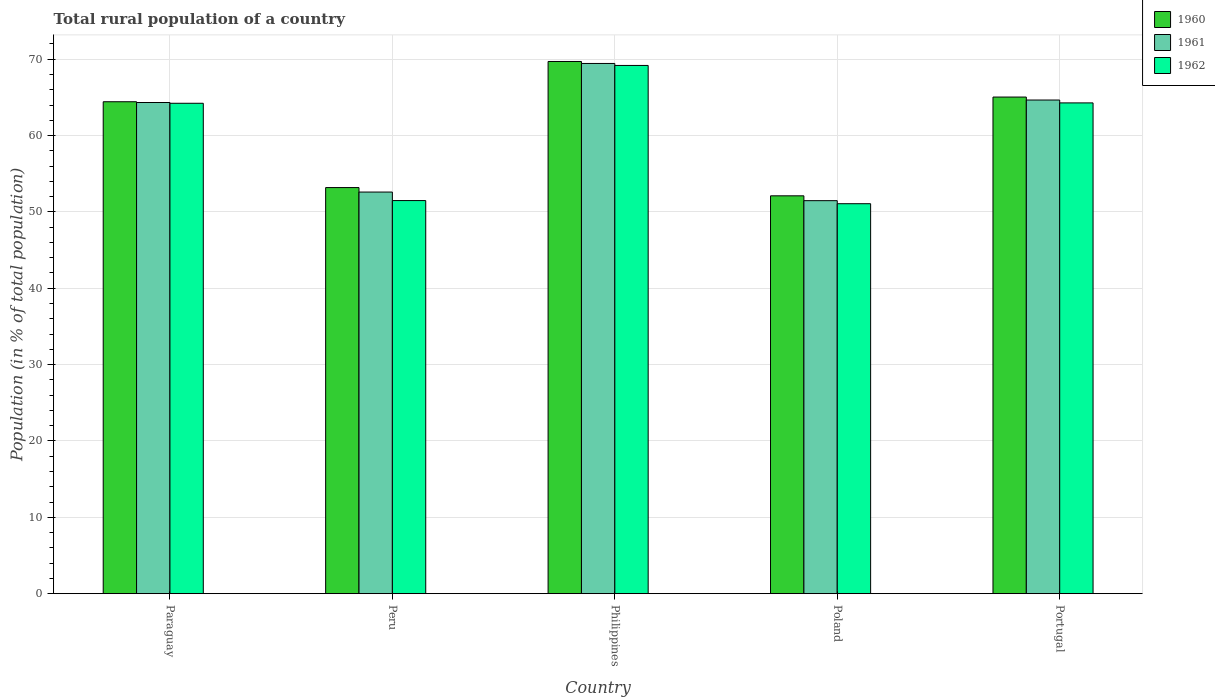How many different coloured bars are there?
Provide a short and direct response. 3. In how many cases, is the number of bars for a given country not equal to the number of legend labels?
Provide a short and direct response. 0. What is the rural population in 1961 in Paraguay?
Your response must be concise. 64.33. Across all countries, what is the maximum rural population in 1962?
Make the answer very short. 69.18. Across all countries, what is the minimum rural population in 1960?
Ensure brevity in your answer.  52.11. In which country was the rural population in 1961 minimum?
Provide a succinct answer. Poland. What is the total rural population in 1961 in the graph?
Your answer should be compact. 302.51. What is the difference between the rural population in 1962 in Paraguay and that in Portugal?
Offer a terse response. -0.05. What is the difference between the rural population in 1962 in Portugal and the rural population in 1960 in Paraguay?
Offer a terse response. -0.15. What is the average rural population in 1962 per country?
Keep it short and to the point. 60.05. What is the difference between the rural population of/in 1962 and rural population of/in 1961 in Philippines?
Give a very brief answer. -0.26. What is the ratio of the rural population in 1960 in Paraguay to that in Poland?
Keep it short and to the point. 1.24. What is the difference between the highest and the second highest rural population in 1961?
Keep it short and to the point. 0.33. What is the difference between the highest and the lowest rural population in 1960?
Make the answer very short. 17.6. In how many countries, is the rural population in 1960 greater than the average rural population in 1960 taken over all countries?
Your answer should be very brief. 3. Is it the case that in every country, the sum of the rural population in 1960 and rural population in 1961 is greater than the rural population in 1962?
Provide a short and direct response. Yes. How many bars are there?
Make the answer very short. 15. What is the difference between two consecutive major ticks on the Y-axis?
Provide a short and direct response. 10. Does the graph contain any zero values?
Your answer should be compact. No. Does the graph contain grids?
Keep it short and to the point. Yes. Where does the legend appear in the graph?
Your response must be concise. Top right. How are the legend labels stacked?
Provide a succinct answer. Vertical. What is the title of the graph?
Your answer should be compact. Total rural population of a country. What is the label or title of the X-axis?
Your answer should be compact. Country. What is the label or title of the Y-axis?
Make the answer very short. Population (in % of total population). What is the Population (in % of total population) in 1960 in Paraguay?
Offer a very short reply. 64.43. What is the Population (in % of total population) of 1961 in Paraguay?
Give a very brief answer. 64.33. What is the Population (in % of total population) in 1962 in Paraguay?
Your answer should be very brief. 64.23. What is the Population (in % of total population) of 1960 in Peru?
Keep it short and to the point. 53.19. What is the Population (in % of total population) of 1961 in Peru?
Your answer should be compact. 52.6. What is the Population (in % of total population) of 1962 in Peru?
Make the answer very short. 51.49. What is the Population (in % of total population) in 1960 in Philippines?
Give a very brief answer. 69.7. What is the Population (in % of total population) of 1961 in Philippines?
Provide a short and direct response. 69.44. What is the Population (in % of total population) in 1962 in Philippines?
Your response must be concise. 69.18. What is the Population (in % of total population) of 1960 in Poland?
Provide a succinct answer. 52.11. What is the Population (in % of total population) of 1961 in Poland?
Provide a short and direct response. 51.47. What is the Population (in % of total population) of 1962 in Poland?
Your answer should be very brief. 51.07. What is the Population (in % of total population) in 1960 in Portugal?
Your answer should be very brief. 65.05. What is the Population (in % of total population) in 1961 in Portugal?
Keep it short and to the point. 64.66. What is the Population (in % of total population) of 1962 in Portugal?
Your answer should be compact. 64.28. Across all countries, what is the maximum Population (in % of total population) in 1960?
Provide a succinct answer. 69.7. Across all countries, what is the maximum Population (in % of total population) of 1961?
Your response must be concise. 69.44. Across all countries, what is the maximum Population (in % of total population) in 1962?
Keep it short and to the point. 69.18. Across all countries, what is the minimum Population (in % of total population) of 1960?
Your response must be concise. 52.11. Across all countries, what is the minimum Population (in % of total population) in 1961?
Your answer should be compact. 51.47. Across all countries, what is the minimum Population (in % of total population) in 1962?
Ensure brevity in your answer.  51.07. What is the total Population (in % of total population) in 1960 in the graph?
Give a very brief answer. 304.48. What is the total Population (in % of total population) of 1961 in the graph?
Keep it short and to the point. 302.51. What is the total Population (in % of total population) of 1962 in the graph?
Provide a short and direct response. 300.25. What is the difference between the Population (in % of total population) of 1960 in Paraguay and that in Peru?
Ensure brevity in your answer.  11.24. What is the difference between the Population (in % of total population) in 1961 in Paraguay and that in Peru?
Make the answer very short. 11.73. What is the difference between the Population (in % of total population) in 1962 in Paraguay and that in Peru?
Make the answer very short. 12.74. What is the difference between the Population (in % of total population) of 1960 in Paraguay and that in Philippines?
Your response must be concise. -5.27. What is the difference between the Population (in % of total population) in 1961 in Paraguay and that in Philippines?
Offer a very short reply. -5.12. What is the difference between the Population (in % of total population) of 1962 in Paraguay and that in Philippines?
Provide a short and direct response. -4.96. What is the difference between the Population (in % of total population) in 1960 in Paraguay and that in Poland?
Give a very brief answer. 12.32. What is the difference between the Population (in % of total population) of 1961 in Paraguay and that in Poland?
Provide a succinct answer. 12.86. What is the difference between the Population (in % of total population) of 1962 in Paraguay and that in Poland?
Your answer should be very brief. 13.15. What is the difference between the Population (in % of total population) in 1960 in Paraguay and that in Portugal?
Make the answer very short. -0.61. What is the difference between the Population (in % of total population) in 1961 in Paraguay and that in Portugal?
Keep it short and to the point. -0.33. What is the difference between the Population (in % of total population) of 1962 in Paraguay and that in Portugal?
Your response must be concise. -0.05. What is the difference between the Population (in % of total population) in 1960 in Peru and that in Philippines?
Your answer should be very brief. -16.51. What is the difference between the Population (in % of total population) of 1961 in Peru and that in Philippines?
Your response must be concise. -16.84. What is the difference between the Population (in % of total population) of 1962 in Peru and that in Philippines?
Ensure brevity in your answer.  -17.7. What is the difference between the Population (in % of total population) in 1960 in Peru and that in Poland?
Provide a succinct answer. 1.08. What is the difference between the Population (in % of total population) in 1961 in Peru and that in Poland?
Provide a succinct answer. 1.13. What is the difference between the Population (in % of total population) of 1962 in Peru and that in Poland?
Your answer should be very brief. 0.41. What is the difference between the Population (in % of total population) in 1960 in Peru and that in Portugal?
Offer a terse response. -11.86. What is the difference between the Population (in % of total population) of 1961 in Peru and that in Portugal?
Offer a very short reply. -12.05. What is the difference between the Population (in % of total population) in 1962 in Peru and that in Portugal?
Your answer should be very brief. -12.79. What is the difference between the Population (in % of total population) of 1960 in Philippines and that in Poland?
Ensure brevity in your answer.  17.59. What is the difference between the Population (in % of total population) in 1961 in Philippines and that in Poland?
Provide a succinct answer. 17.97. What is the difference between the Population (in % of total population) in 1962 in Philippines and that in Poland?
Keep it short and to the point. 18.11. What is the difference between the Population (in % of total population) in 1960 in Philippines and that in Portugal?
Keep it short and to the point. 4.66. What is the difference between the Population (in % of total population) in 1961 in Philippines and that in Portugal?
Give a very brief answer. 4.79. What is the difference between the Population (in % of total population) in 1962 in Philippines and that in Portugal?
Your answer should be compact. 4.91. What is the difference between the Population (in % of total population) in 1960 in Poland and that in Portugal?
Your response must be concise. -12.94. What is the difference between the Population (in % of total population) in 1961 in Poland and that in Portugal?
Keep it short and to the point. -13.18. What is the difference between the Population (in % of total population) in 1962 in Poland and that in Portugal?
Your response must be concise. -13.2. What is the difference between the Population (in % of total population) in 1960 in Paraguay and the Population (in % of total population) in 1961 in Peru?
Your response must be concise. 11.83. What is the difference between the Population (in % of total population) in 1960 in Paraguay and the Population (in % of total population) in 1962 in Peru?
Make the answer very short. 12.95. What is the difference between the Population (in % of total population) of 1961 in Paraguay and the Population (in % of total population) of 1962 in Peru?
Your answer should be compact. 12.84. What is the difference between the Population (in % of total population) of 1960 in Paraguay and the Population (in % of total population) of 1961 in Philippines?
Give a very brief answer. -5.01. What is the difference between the Population (in % of total population) in 1960 in Paraguay and the Population (in % of total population) in 1962 in Philippines?
Offer a terse response. -4.75. What is the difference between the Population (in % of total population) in 1961 in Paraguay and the Population (in % of total population) in 1962 in Philippines?
Provide a short and direct response. -4.85. What is the difference between the Population (in % of total population) of 1960 in Paraguay and the Population (in % of total population) of 1961 in Poland?
Make the answer very short. 12.96. What is the difference between the Population (in % of total population) of 1960 in Paraguay and the Population (in % of total population) of 1962 in Poland?
Keep it short and to the point. 13.36. What is the difference between the Population (in % of total population) in 1961 in Paraguay and the Population (in % of total population) in 1962 in Poland?
Offer a terse response. 13.26. What is the difference between the Population (in % of total population) of 1960 in Paraguay and the Population (in % of total population) of 1961 in Portugal?
Give a very brief answer. -0.23. What is the difference between the Population (in % of total population) of 1960 in Paraguay and the Population (in % of total population) of 1962 in Portugal?
Give a very brief answer. 0.15. What is the difference between the Population (in % of total population) of 1961 in Paraguay and the Population (in % of total population) of 1962 in Portugal?
Keep it short and to the point. 0.05. What is the difference between the Population (in % of total population) in 1960 in Peru and the Population (in % of total population) in 1961 in Philippines?
Your response must be concise. -16.26. What is the difference between the Population (in % of total population) in 1960 in Peru and the Population (in % of total population) in 1962 in Philippines?
Give a very brief answer. -15.99. What is the difference between the Population (in % of total population) of 1961 in Peru and the Population (in % of total population) of 1962 in Philippines?
Your answer should be very brief. -16.58. What is the difference between the Population (in % of total population) of 1960 in Peru and the Population (in % of total population) of 1961 in Poland?
Offer a very short reply. 1.72. What is the difference between the Population (in % of total population) in 1960 in Peru and the Population (in % of total population) in 1962 in Poland?
Your answer should be very brief. 2.12. What is the difference between the Population (in % of total population) in 1961 in Peru and the Population (in % of total population) in 1962 in Poland?
Your response must be concise. 1.53. What is the difference between the Population (in % of total population) in 1960 in Peru and the Population (in % of total population) in 1961 in Portugal?
Ensure brevity in your answer.  -11.47. What is the difference between the Population (in % of total population) in 1960 in Peru and the Population (in % of total population) in 1962 in Portugal?
Your answer should be compact. -11.09. What is the difference between the Population (in % of total population) of 1961 in Peru and the Population (in % of total population) of 1962 in Portugal?
Keep it short and to the point. -11.68. What is the difference between the Population (in % of total population) of 1960 in Philippines and the Population (in % of total population) of 1961 in Poland?
Your answer should be compact. 18.23. What is the difference between the Population (in % of total population) of 1960 in Philippines and the Population (in % of total population) of 1962 in Poland?
Your answer should be compact. 18.63. What is the difference between the Population (in % of total population) of 1961 in Philippines and the Population (in % of total population) of 1962 in Poland?
Offer a terse response. 18.37. What is the difference between the Population (in % of total population) of 1960 in Philippines and the Population (in % of total population) of 1961 in Portugal?
Offer a terse response. 5.05. What is the difference between the Population (in % of total population) in 1960 in Philippines and the Population (in % of total population) in 1962 in Portugal?
Offer a terse response. 5.42. What is the difference between the Population (in % of total population) in 1961 in Philippines and the Population (in % of total population) in 1962 in Portugal?
Keep it short and to the point. 5.17. What is the difference between the Population (in % of total population) of 1960 in Poland and the Population (in % of total population) of 1961 in Portugal?
Your answer should be compact. -12.55. What is the difference between the Population (in % of total population) in 1960 in Poland and the Population (in % of total population) in 1962 in Portugal?
Offer a very short reply. -12.17. What is the difference between the Population (in % of total population) in 1961 in Poland and the Population (in % of total population) in 1962 in Portugal?
Provide a succinct answer. -12.8. What is the average Population (in % of total population) in 1960 per country?
Provide a succinct answer. 60.9. What is the average Population (in % of total population) of 1961 per country?
Your answer should be very brief. 60.5. What is the average Population (in % of total population) in 1962 per country?
Your response must be concise. 60.05. What is the difference between the Population (in % of total population) of 1960 and Population (in % of total population) of 1961 in Paraguay?
Your answer should be compact. 0.1. What is the difference between the Population (in % of total population) of 1960 and Population (in % of total population) of 1962 in Paraguay?
Provide a short and direct response. 0.2. What is the difference between the Population (in % of total population) in 1961 and Population (in % of total population) in 1962 in Paraguay?
Provide a succinct answer. 0.1. What is the difference between the Population (in % of total population) of 1960 and Population (in % of total population) of 1961 in Peru?
Make the answer very short. 0.59. What is the difference between the Population (in % of total population) of 1960 and Population (in % of total population) of 1962 in Peru?
Make the answer very short. 1.7. What is the difference between the Population (in % of total population) of 1961 and Population (in % of total population) of 1962 in Peru?
Offer a terse response. 1.12. What is the difference between the Population (in % of total population) of 1960 and Population (in % of total population) of 1961 in Philippines?
Your answer should be very brief. 0.26. What is the difference between the Population (in % of total population) of 1960 and Population (in % of total population) of 1962 in Philippines?
Your response must be concise. 0.52. What is the difference between the Population (in % of total population) of 1961 and Population (in % of total population) of 1962 in Philippines?
Offer a very short reply. 0.26. What is the difference between the Population (in % of total population) of 1960 and Population (in % of total population) of 1961 in Poland?
Offer a terse response. 0.64. What is the difference between the Population (in % of total population) in 1960 and Population (in % of total population) in 1962 in Poland?
Your response must be concise. 1.03. What is the difference between the Population (in % of total population) of 1961 and Population (in % of total population) of 1962 in Poland?
Offer a very short reply. 0.4. What is the difference between the Population (in % of total population) in 1960 and Population (in % of total population) in 1961 in Portugal?
Your response must be concise. 0.39. What is the difference between the Population (in % of total population) of 1960 and Population (in % of total population) of 1962 in Portugal?
Offer a very short reply. 0.77. What is the difference between the Population (in % of total population) in 1961 and Population (in % of total population) in 1962 in Portugal?
Your answer should be very brief. 0.38. What is the ratio of the Population (in % of total population) in 1960 in Paraguay to that in Peru?
Your response must be concise. 1.21. What is the ratio of the Population (in % of total population) in 1961 in Paraguay to that in Peru?
Ensure brevity in your answer.  1.22. What is the ratio of the Population (in % of total population) of 1962 in Paraguay to that in Peru?
Provide a short and direct response. 1.25. What is the ratio of the Population (in % of total population) of 1960 in Paraguay to that in Philippines?
Make the answer very short. 0.92. What is the ratio of the Population (in % of total population) of 1961 in Paraguay to that in Philippines?
Provide a succinct answer. 0.93. What is the ratio of the Population (in % of total population) of 1962 in Paraguay to that in Philippines?
Provide a short and direct response. 0.93. What is the ratio of the Population (in % of total population) in 1960 in Paraguay to that in Poland?
Keep it short and to the point. 1.24. What is the ratio of the Population (in % of total population) in 1961 in Paraguay to that in Poland?
Offer a very short reply. 1.25. What is the ratio of the Population (in % of total population) of 1962 in Paraguay to that in Poland?
Ensure brevity in your answer.  1.26. What is the ratio of the Population (in % of total population) in 1960 in Paraguay to that in Portugal?
Ensure brevity in your answer.  0.99. What is the ratio of the Population (in % of total population) in 1961 in Paraguay to that in Portugal?
Make the answer very short. 0.99. What is the ratio of the Population (in % of total population) in 1960 in Peru to that in Philippines?
Your response must be concise. 0.76. What is the ratio of the Population (in % of total population) in 1961 in Peru to that in Philippines?
Your response must be concise. 0.76. What is the ratio of the Population (in % of total population) in 1962 in Peru to that in Philippines?
Offer a very short reply. 0.74. What is the ratio of the Population (in % of total population) in 1960 in Peru to that in Poland?
Provide a succinct answer. 1.02. What is the ratio of the Population (in % of total population) in 1961 in Peru to that in Poland?
Your answer should be compact. 1.02. What is the ratio of the Population (in % of total population) of 1962 in Peru to that in Poland?
Keep it short and to the point. 1.01. What is the ratio of the Population (in % of total population) of 1960 in Peru to that in Portugal?
Provide a succinct answer. 0.82. What is the ratio of the Population (in % of total population) of 1961 in Peru to that in Portugal?
Your answer should be very brief. 0.81. What is the ratio of the Population (in % of total population) of 1962 in Peru to that in Portugal?
Your response must be concise. 0.8. What is the ratio of the Population (in % of total population) of 1960 in Philippines to that in Poland?
Make the answer very short. 1.34. What is the ratio of the Population (in % of total population) in 1961 in Philippines to that in Poland?
Make the answer very short. 1.35. What is the ratio of the Population (in % of total population) in 1962 in Philippines to that in Poland?
Make the answer very short. 1.35. What is the ratio of the Population (in % of total population) in 1960 in Philippines to that in Portugal?
Give a very brief answer. 1.07. What is the ratio of the Population (in % of total population) of 1961 in Philippines to that in Portugal?
Give a very brief answer. 1.07. What is the ratio of the Population (in % of total population) in 1962 in Philippines to that in Portugal?
Offer a very short reply. 1.08. What is the ratio of the Population (in % of total population) in 1960 in Poland to that in Portugal?
Provide a succinct answer. 0.8. What is the ratio of the Population (in % of total population) in 1961 in Poland to that in Portugal?
Offer a terse response. 0.8. What is the ratio of the Population (in % of total population) of 1962 in Poland to that in Portugal?
Your response must be concise. 0.79. What is the difference between the highest and the second highest Population (in % of total population) of 1960?
Give a very brief answer. 4.66. What is the difference between the highest and the second highest Population (in % of total population) in 1961?
Provide a short and direct response. 4.79. What is the difference between the highest and the second highest Population (in % of total population) of 1962?
Provide a succinct answer. 4.91. What is the difference between the highest and the lowest Population (in % of total population) of 1960?
Make the answer very short. 17.59. What is the difference between the highest and the lowest Population (in % of total population) of 1961?
Offer a very short reply. 17.97. What is the difference between the highest and the lowest Population (in % of total population) of 1962?
Your answer should be compact. 18.11. 